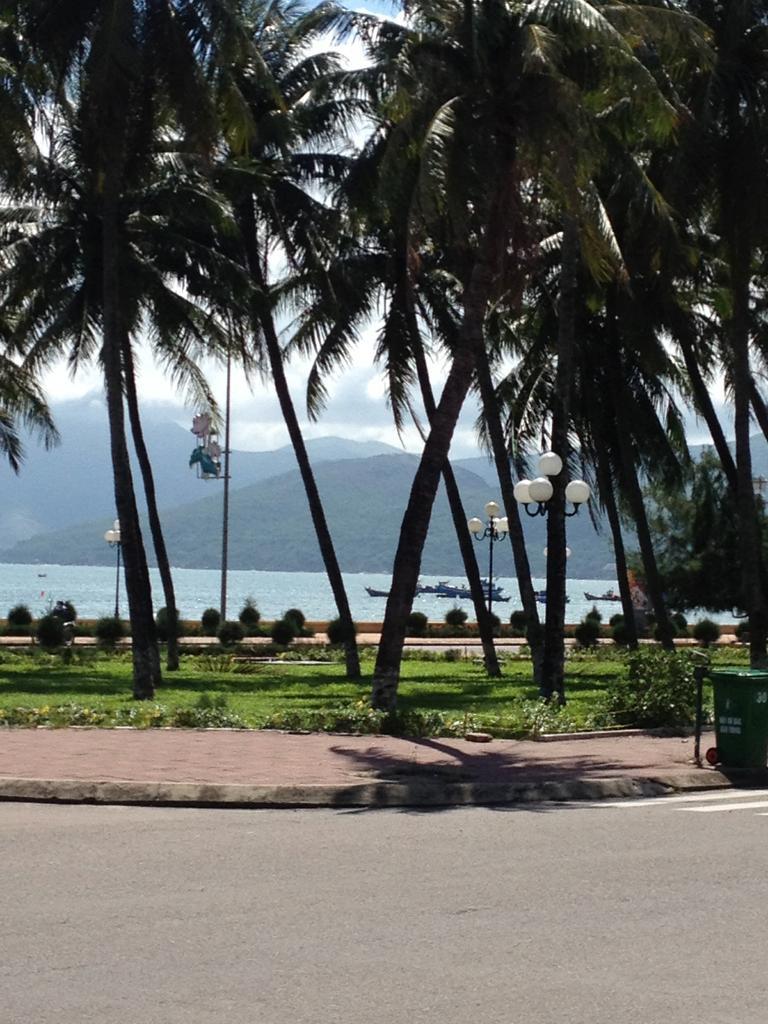In one or two sentences, can you explain what this image depicts? In this image, we can see trees, hills, light poles, plants, a bin and there are boats on the water. At the bottom, there is a road. 